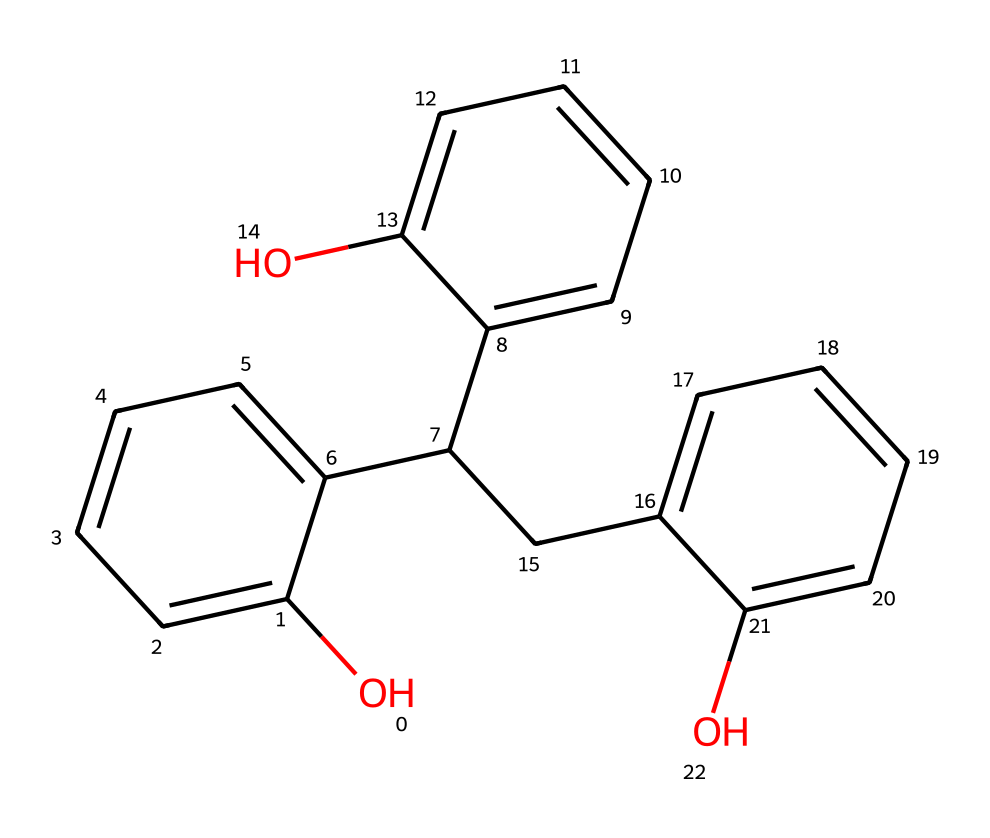how many hydroxyl groups are in this chemical? The chemical structure includes three -OH groups, which can be identified by locating the hydroxyl functional groups present in the compound.
Answer: three what is the primary aromatic structure present in this chemical? The chemical contains a phenolic structure, which is characterized by a benzene ring connected to a hydroxyl group. The presence of multiple benzene rings indicates it's a phenolic polymer.
Answer: phenolic how many carbon atoms are in this compound? By analyzing the structure closely, you can count the total number of carbon atoms connected within the formula. In this case, there are 15 carbon atoms.
Answer: 15 what type of polymer is formed from this chemical? This chemical is categorized as a thermosetting polymer due to its cross-linked network formed during the polymerization process, making it rigid and heat-resistant.
Answer: thermosetting what feature of this polymer contributes to its use in gas mask filters? The presence of hydroxyl groups in the structure increases its adsorptive properties, allowing it to effectively trap toxic gases and vapors, which is essential for gas mask functionality.
Answer: adsorptive properties how many rings are present in this chemical structure? In the SMILES representation, it shows three distinct benzene rings. You can identify these rings through the cyclic structure notations in the representation.
Answer: three 